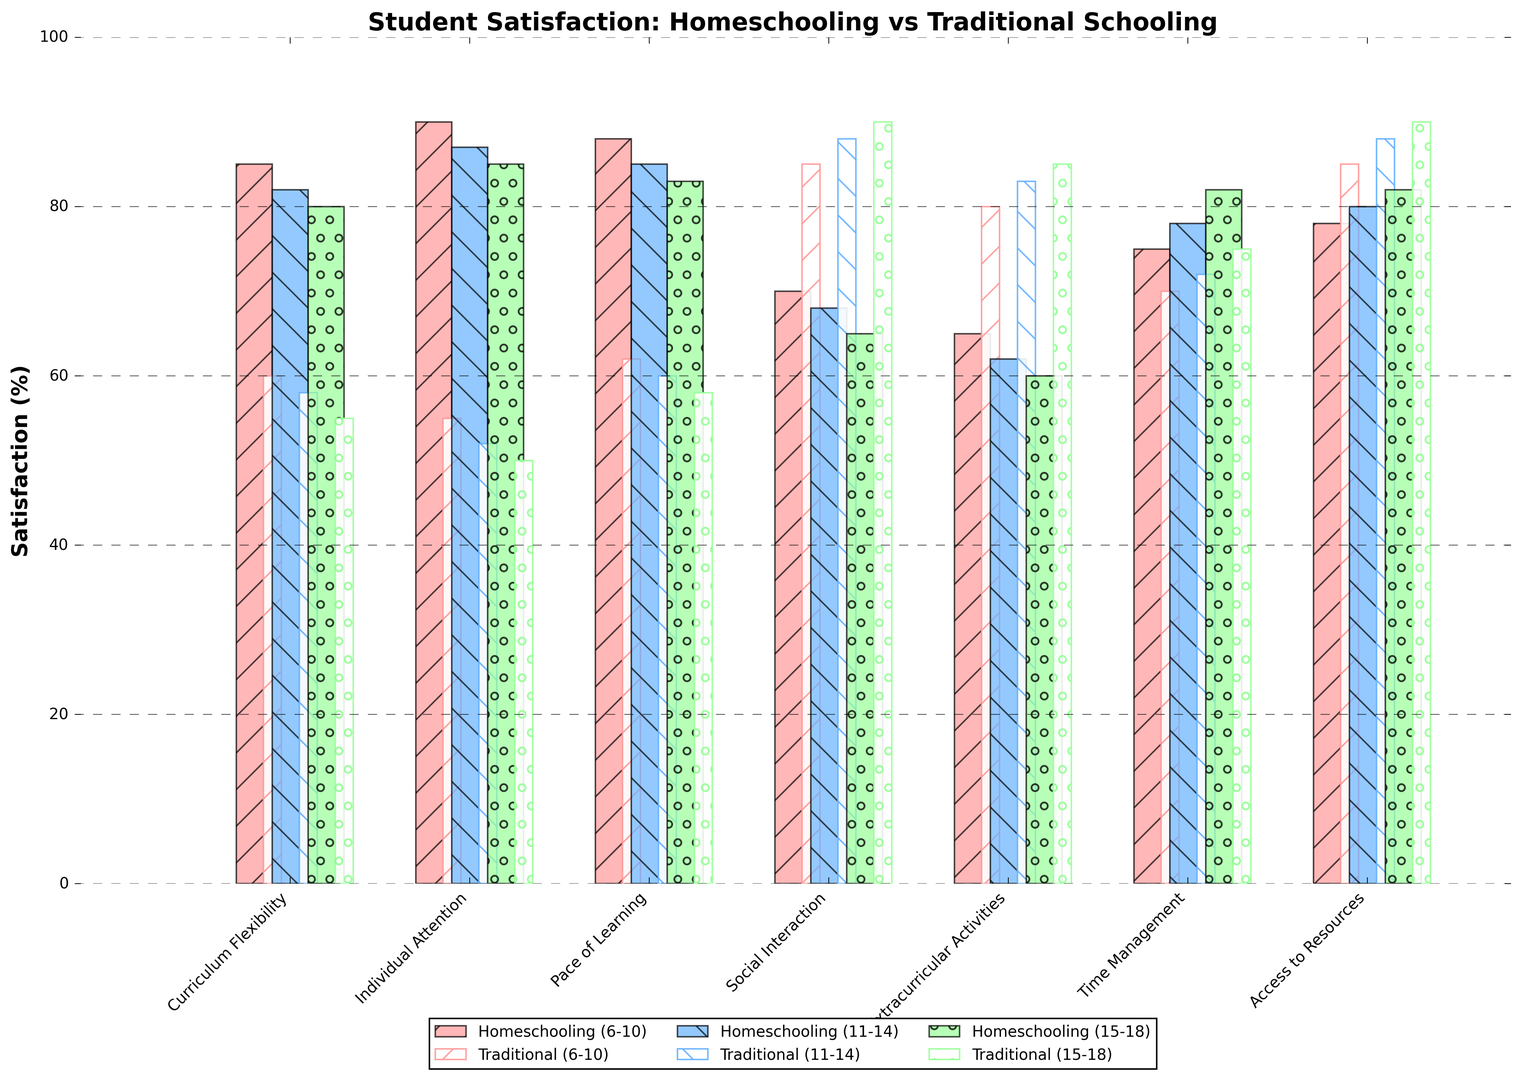What age group shows the highest satisfaction in Individual Attention with homeschooling? The age group with the highest satisfaction in Individual Attention can be identified by comparing the height of the bars representing homeschooling satisfaction in Individual Attention across all age groups. The bars for the age groups are 6-10, 11-14, and 15-18. For Individual Attention, 6-10 is at 90%, 11-14 is at 87%, and 15-18 is at 85%. Thus, 6-10 has the highest satisfaction rate.
Answer: 6-10 Which aspect shows the largest difference in satisfaction between homeschooling and traditional schooling for the 15-18 age group? To find the largest difference in satisfaction between homeschooling and traditional schooling, we compare the bars for each aspect within the 15-18 age group. Calculate the absolute difference for each aspect: Curriculum Flexibility (80-55)=25, Individual Attention (85-50)=35, Pace of Learning (83-58)=25, Social Interaction (65-90)=25, Extracurricular Activities (60-85)=25, Time Management (82-75)=7, and Access to Resources (82-90)=8. The largest difference is for Individual Attention with a value of 35%.
Answer: Individual Attention What is the average satisfaction rate for Extracurricular Activities in both traditional and homeschooling for 11-14 age group? For 11-14 age group, the satisfaction rates for Extracurricular Activities are 62% for homeschooling and 83% for traditional schooling. To find the average, sum up the two rates and then divide by 2: (62+83)/2 = 145/2 = 72.5.
Answer: 72.5% Is the satisfaction rate for Social Interaction higher in homeschooling or traditional schooling for the 6-10 age group? Looking at the bars representing Social Interaction satisfaction rates for 6-10 age group, homeschooling satisfaction is 70% and traditional schooling satisfaction is 85%. Since 85% is higher than 70%, traditional schooling has a higher satisfaction rate for Social Interaction in this age group.
Answer: Traditional schooling In which aspect do all age groups show higher satisfaction with homeschooling compared to traditional schooling? We need to compare all age groups' satisfaction levels for each aspect. Reviewing each aspect: Curriculum Flexibility (all homeschooling > traditional), Individual Attention (all homeschooling > traditional), Pace of Learning (all homeschooling > traditional), Social Interaction (all traditional > homeschooling), Extracurricular Activities (all traditional > homeschooling), Time Management (all homeschooling > traditional), Access to Resources (all traditional > homeschooling). The aspects where all age groups show higher satisfaction with homeschooling are Curriculum Flexibility, Individual Attention, Pace of Learning, and Time Management.
Answer: Curriculum Flexibility, Individual Attention, Pace of Learning, Time Management 